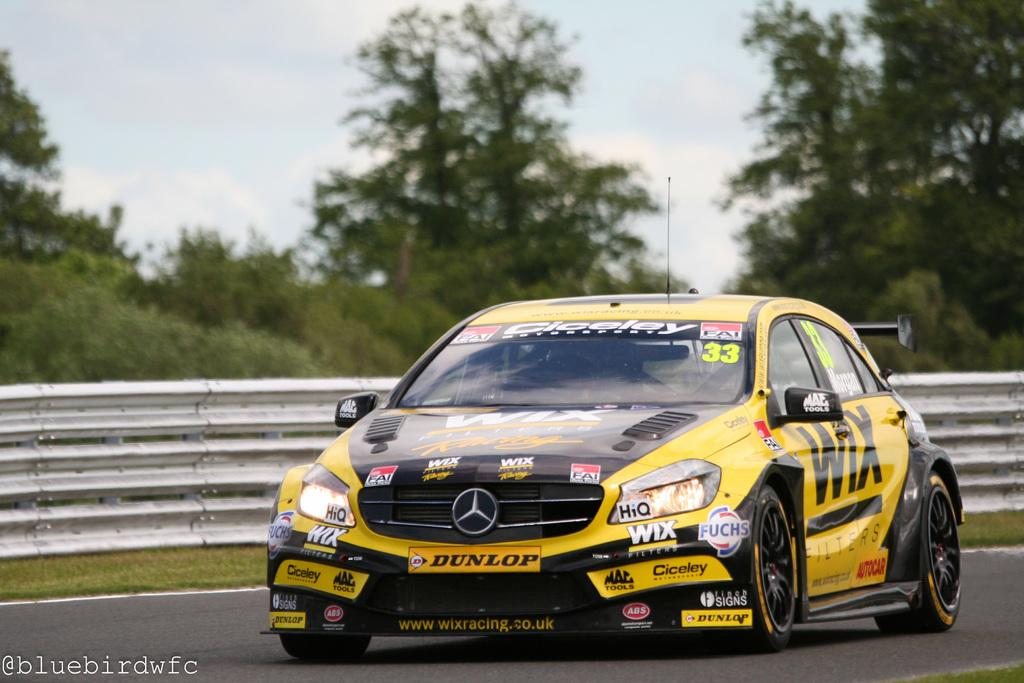<image>
Render a clear and concise summary of the photo. A Mercedes race car that says Dunlop on the front is racing down the track. 